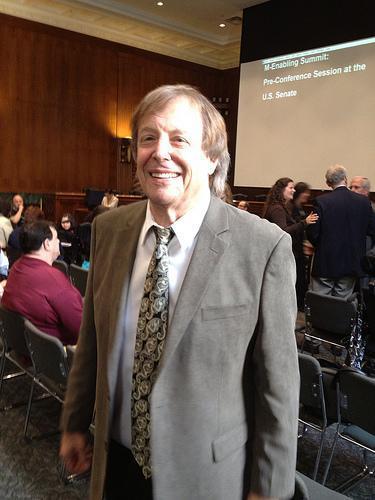How many people are standing?
Give a very brief answer. 5. How many lines of text on the large screen do not contain an n-dash?
Give a very brief answer. 1. 